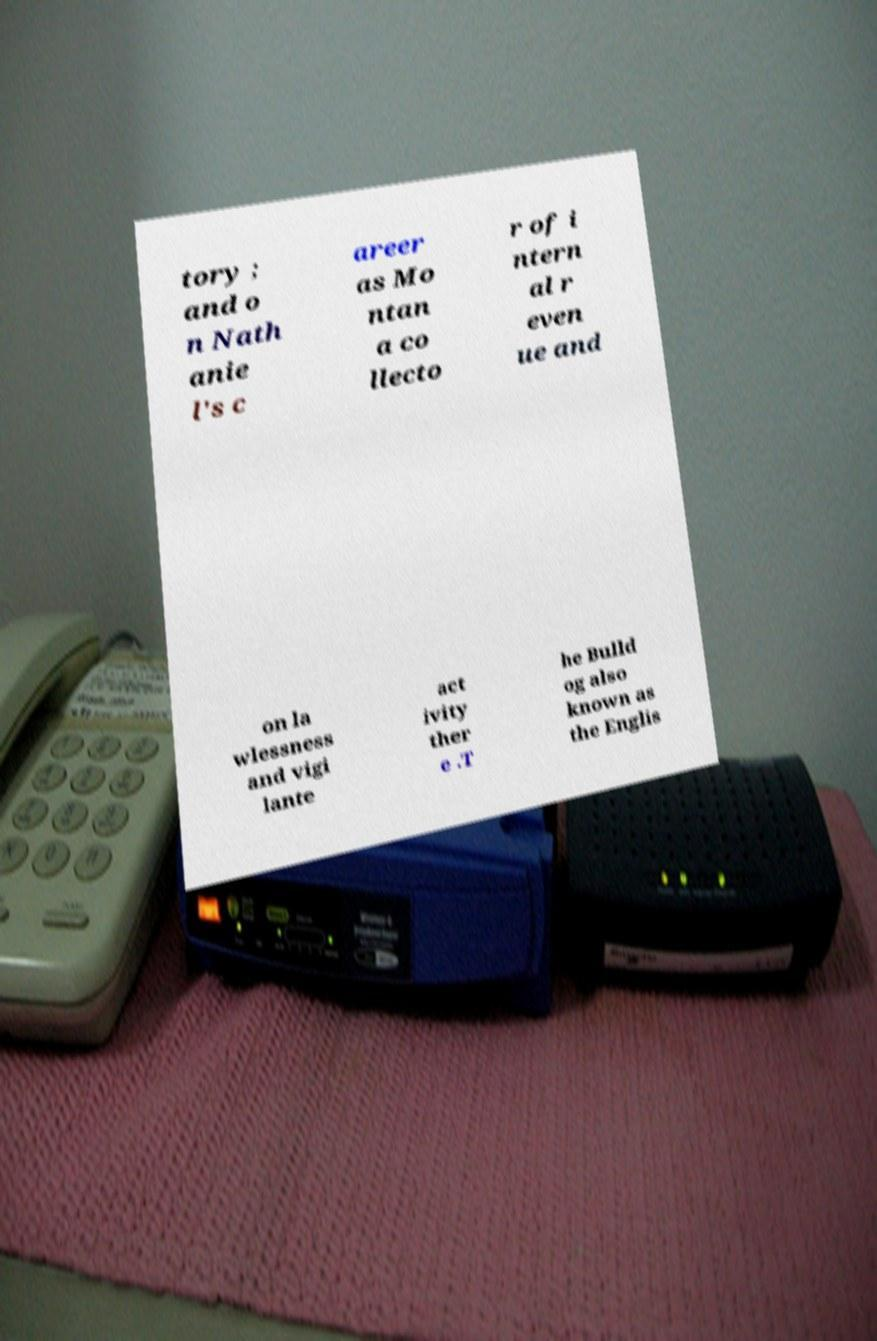Can you accurately transcribe the text from the provided image for me? tory ; and o n Nath anie l's c areer as Mo ntan a co llecto r of i ntern al r even ue and on la wlessness and vigi lante act ivity ther e .T he Bulld og also known as the Englis 